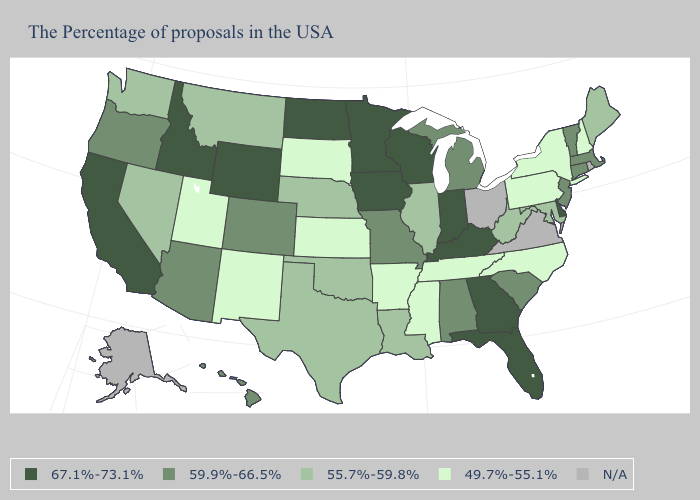What is the value of Minnesota?
Answer briefly. 67.1%-73.1%. Name the states that have a value in the range 67.1%-73.1%?
Short answer required. Delaware, Florida, Georgia, Kentucky, Indiana, Wisconsin, Minnesota, Iowa, North Dakota, Wyoming, Idaho, California. Does Kansas have the lowest value in the USA?
Short answer required. Yes. What is the value of North Dakota?
Short answer required. 67.1%-73.1%. Which states have the lowest value in the South?
Short answer required. North Carolina, Tennessee, Mississippi, Arkansas. Does Connecticut have the lowest value in the Northeast?
Concise answer only. No. Name the states that have a value in the range 67.1%-73.1%?
Concise answer only. Delaware, Florida, Georgia, Kentucky, Indiana, Wisconsin, Minnesota, Iowa, North Dakota, Wyoming, Idaho, California. Which states have the lowest value in the West?
Answer briefly. New Mexico, Utah. Does Indiana have the highest value in the USA?
Concise answer only. Yes. Name the states that have a value in the range 55.7%-59.8%?
Give a very brief answer. Maine, Maryland, West Virginia, Illinois, Louisiana, Nebraska, Oklahoma, Texas, Montana, Nevada, Washington. What is the value of Wisconsin?
Keep it brief. 67.1%-73.1%. Among the states that border New Mexico , which have the highest value?
Quick response, please. Colorado, Arizona. Which states have the highest value in the USA?
Be succinct. Delaware, Florida, Georgia, Kentucky, Indiana, Wisconsin, Minnesota, Iowa, North Dakota, Wyoming, Idaho, California. Name the states that have a value in the range 59.9%-66.5%?
Answer briefly. Massachusetts, Vermont, Connecticut, New Jersey, South Carolina, Michigan, Alabama, Missouri, Colorado, Arizona, Oregon, Hawaii. 